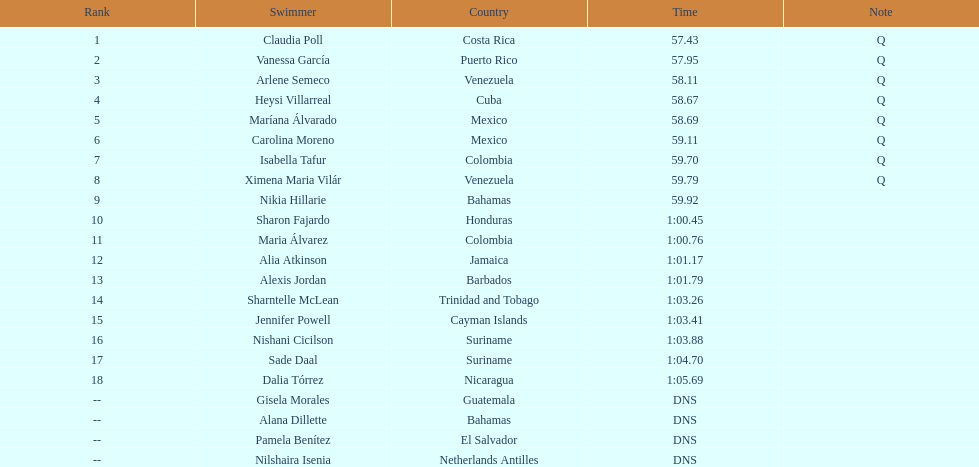How many competitors from venezuela qualified for the final? 2. 